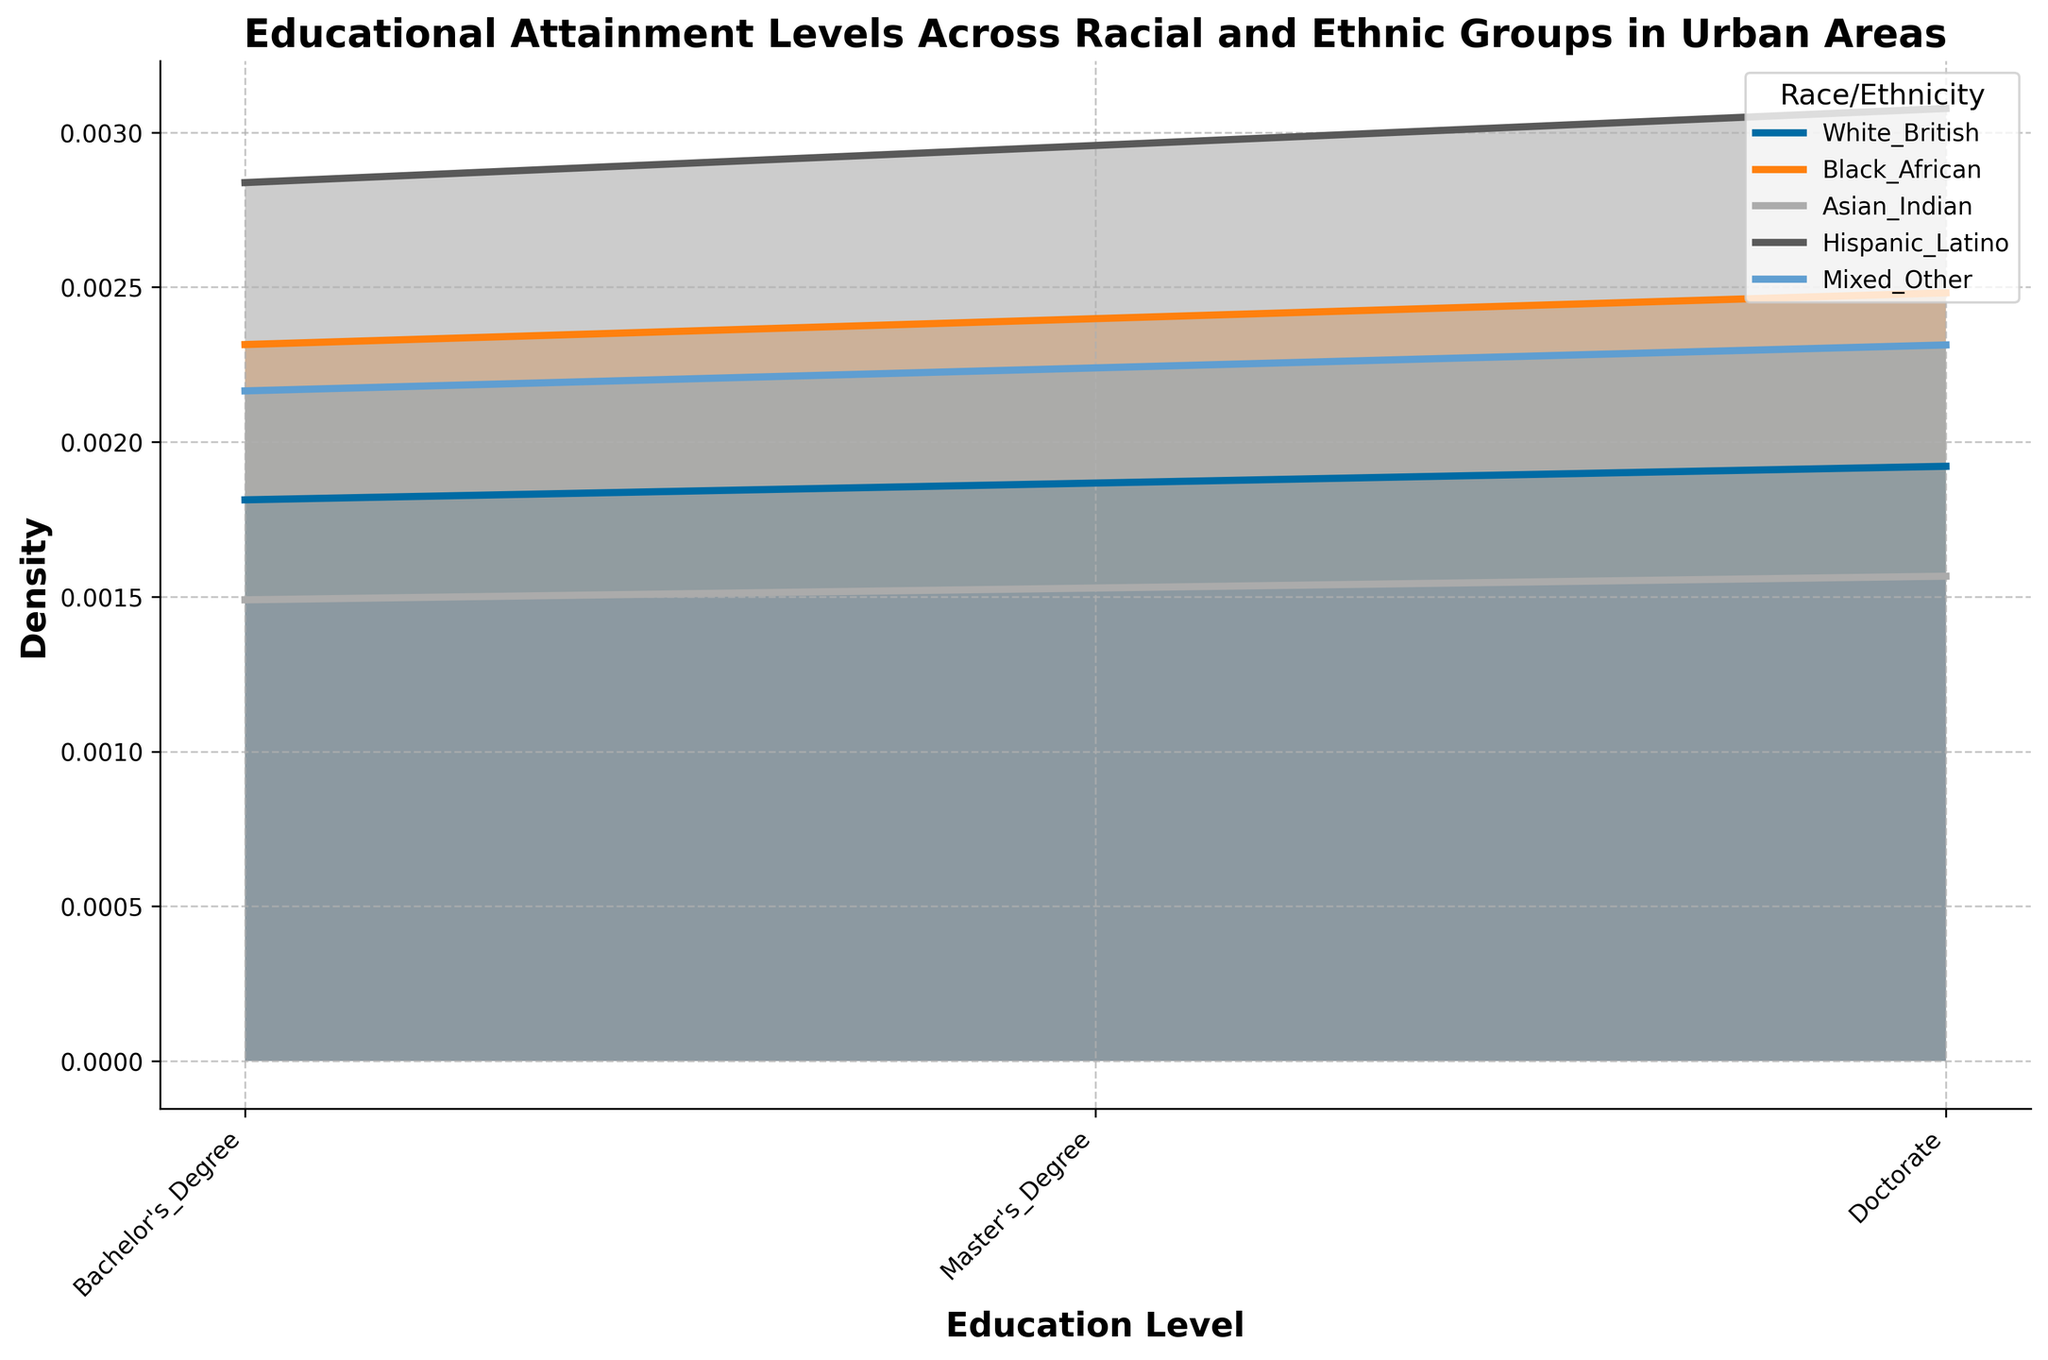What is the title of the density plot? The title of any plot is usually located at the top center of the figure. By observing the top center of the density plot, we can identify the title.
Answer: Educational Attainment Levels Across Racial and Ethnic Groups in Urban Areas How many educational levels are shown in the plot? The number of educational levels can be determined by looking at the x-axis labels, which display different education levels. Count these labels to get the number.
Answer: 3 Which racial/ethnic group has the highest density at the Bachelor's Degree level? Look at the peaks of the density curves corresponding to the Bachelor's Degree level along the x-axis. The group with the highest peak has the highest density for that level.
Answer: Asian Indian Among the racial/ethnic groups shown, which has the lowest density in the Doctorate education level? Examine the peaks of the density curves at the Doctorate level on the x-axis. The curve with the lowest peak at this level represents the lowest density.
Answer: Hispanic Latino Which group shows a higher density at the Master’s Degree level: White British or Black African? Compare the heights of the density peaks for White British and Black African at the Master’s Degree level along the x-axis to see which is higher.
Answer: White British What is the general shape of the density curves, and what do they indicate? The density curves typically have peaks and valleys. Peaks indicate higher frequency of individuals at certain educational levels, while valleys indicate lower frequencies. Analyze the general shape of each curve to understand the density distribution.
Answer: Peaks and valleys indicating varying densities Between which pairs of education levels do the major density differences occur for Asian Indian individuals? For the Asian Indian curve, observe where there are sharp changes in density values between adjacent education levels. The pairs of levels with the largest differences indicate major density changes.
Answer: Bachelor's Degree and Master’s Degree How does the density of Mixed/Other individuals at the Bachelor’s Degree level compare to their density at the Master’s Degree level? Look at the density peaks for Mixed/Other at both the Bachelor’s and Master’s Degree levels and compare their heights.
Answer: Higher at the Bachelor’s Degree level How does the total density of Master's and Doctorate levels for Hispanic/Latino compare to that for Black African? Sum the densities of the Master's and Doctorate levels for both Hispanic/Latino and Black African groups to compare their total densities.
Answer: Black African has higher total density What can the overlapping areas of the density curves tell us about the distribution of educational attainment across groups? Overlapping areas suggest that multiple groups have similar densities at particular educational levels. This can indicate common distributions and frequencies in educational attainment.
Answer: Similar educational distributions across groups 